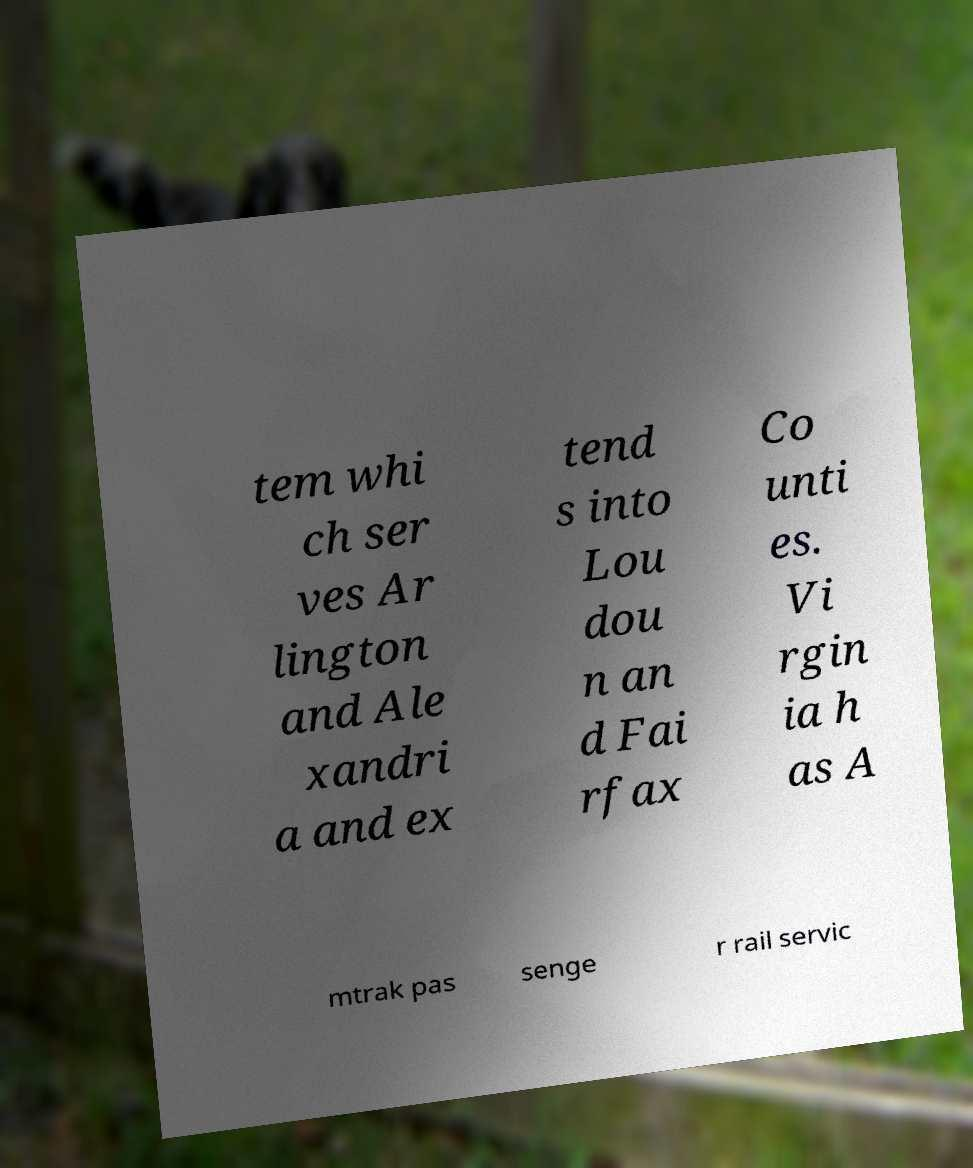Please read and relay the text visible in this image. What does it say? tem whi ch ser ves Ar lington and Ale xandri a and ex tend s into Lou dou n an d Fai rfax Co unti es. Vi rgin ia h as A mtrak pas senge r rail servic 